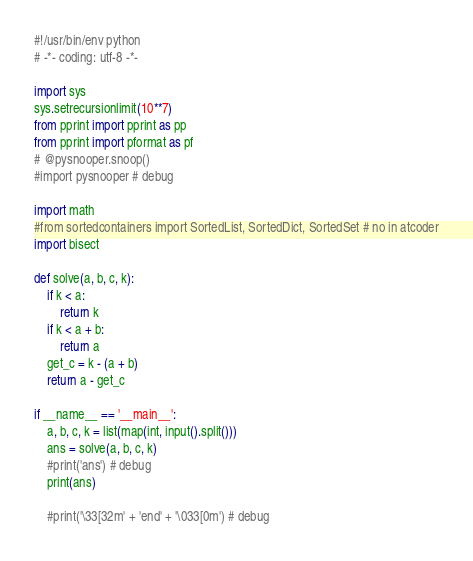<code> <loc_0><loc_0><loc_500><loc_500><_Python_>#!/usr/bin/env python
# -*- coding: utf-8 -*-

import sys
sys.setrecursionlimit(10**7)
from pprint import pprint as pp
from pprint import pformat as pf
# @pysnooper.snoop()
#import pysnooper # debug

import math
#from sortedcontainers import SortedList, SortedDict, SortedSet # no in atcoder
import bisect

def solve(a, b, c, k):
    if k < a:
        return k
    if k < a + b:
        return a
    get_c = k - (a + b)
    return a - get_c

if __name__ == '__main__':
    a, b, c, k = list(map(int, input().split()))
    ans = solve(a, b, c, k)
    #print('ans') # debug
    print(ans)

    #print('\33[32m' + 'end' + '\033[0m') # debug
</code> 